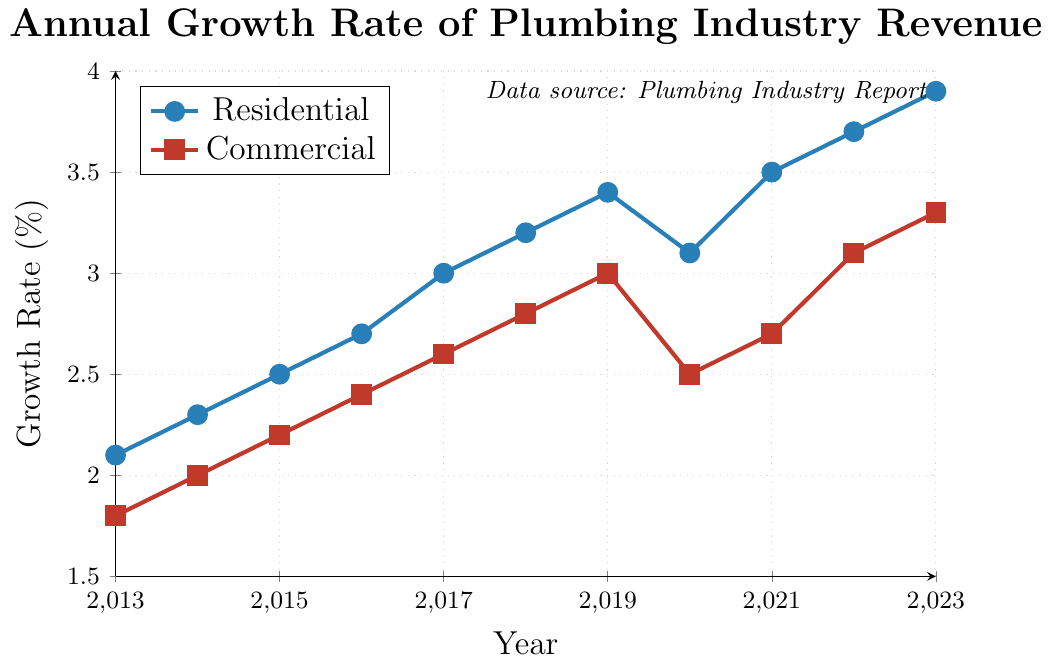What was the annual growth rate for the residential sector in 2020? Look at the Residential plot and find the data point for 2020.
Answer: 3.1% Which sector had a higher growth rate in 2018? Compare the growth rates of the residential and commercial sectors in 2018 by looking at the respective data points.
Answer: Residential What is the difference in growth rates between the residential and commercial sectors in 2023? Find the data points for both sectors in 2023 and subtract the commercial growth rate from the residential growth rate: 3.9 - 3.3.
Answer: 0.6% How did the growth rate in the residential sector change from 2019 to 2020? Look at the data points for the residential sector in 2019 and 2020, then calculate the difference: 3.4 - 3.1.
Answer: -0.3% What's the average growth rate for the residential sector over the entire period? Add up all the growth rates for the residential sector from 2013 to 2023 and divide by the number of years (11): (2.1 + 2.3 + 2.5 + 2.7 + 3.0 + 3.2 + 3.4 + 3.1 + 3.5 + 3.7 + 3.9) / 11.
Answer: 3.02% Between which two consecutive years did the commercial sector see the largest growth rate increase? Review the year-on-year growth rates for all consecutive years for the commercial sector and identify the largest increase: (2013-2014, ... ,2022-2023).
Answer: 2019-2020 What visualization style is used for representing the commercial sector's growth rates? Identify the visual attributes such as the type of markers and color used for the commercial sector's plot.
Answer: Red with square markers In which year did the residential sector first surpass a 3% growth rate? Examine the residential sector's data points and find the first year with a growth rate exceeding 3%.
Answer: 2017 How many years did it take for the residential sector's growth rate to increase from 2.1% to 3.9%? Subtract the initial year (2013) from the final year (2023).
Answer: 10 years What was the cumulative growth rate increase for the commercial sector from 2013 to 2016? Calculate the total increase by summing the year-on-year differences from 2013 to 2016 for the commercial sector (2014-2013 + 2015-2014 + 2016-2015): (2.0-1.8) + (2.2-2.0) + (2.4-2.2).
Answer: 0.6% 